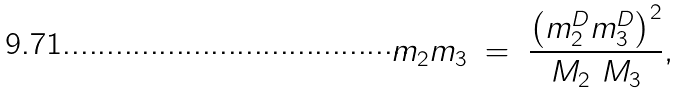<formula> <loc_0><loc_0><loc_500><loc_500>m _ { 2 } m _ { 3 } \ = \ \frac { \left ( m _ { 2 } ^ { D } m _ { 3 } ^ { D } \right ) ^ { 2 } } { M _ { 2 } \ M _ { 3 } } ,</formula> 